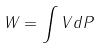<formula> <loc_0><loc_0><loc_500><loc_500>W = \int V d P</formula> 